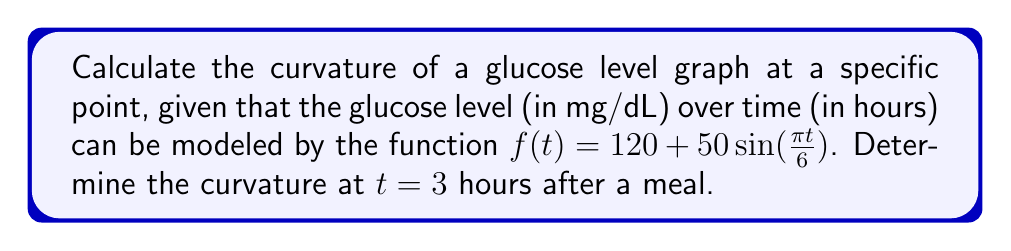Can you solve this math problem? To calculate the curvature of the glucose level graph, we'll use the formula for the curvature of a function:

$$\kappa(t) = \frac{|f''(t)|}{(1 + (f'(t))^2)^{3/2}}$$

Step 1: Find $f'(t)$ and $f''(t)$
$f'(t) = 50 \cdot \frac{\pi}{6} \cos(\frac{\pi t}{6})$
$f''(t) = -50 \cdot (\frac{\pi}{6})^2 \sin(\frac{\pi t}{6})$

Step 2: Evaluate $f'(t)$ and $f''(t)$ at $t = 3$
$f'(3) = 50 \cdot \frac{\pi}{6} \cos(\frac{\pi \cdot 3}{6}) = 50 \cdot \frac{\pi}{6} \cos(\frac{\pi}{2}) = 0$
$f''(3) = -50 \cdot (\frac{\pi}{6})^2 \sin(\frac{\pi \cdot 3}{6}) = -50 \cdot (\frac{\pi}{6})^2 \sin(\frac{\pi}{2}) = -50 \cdot (\frac{\pi}{6})^2$

Step 3: Calculate the curvature using the formula
$$\kappa(3) = \frac{|f''(3)|}{(1 + (f'(3))^2)^{3/2}}$$

$$\kappa(3) = \frac{|-50 \cdot (\frac{\pi}{6})^2|}{(1 + 0^2)^{3/2}}$$

$$\kappa(3) = |-50 \cdot (\frac{\pi}{6})^2| = 50 \cdot (\frac{\pi}{6})^2 \approx 1.37$$
Answer: $\kappa(3) = 50 \cdot (\frac{\pi}{6})^2 \approx 1.37$ 